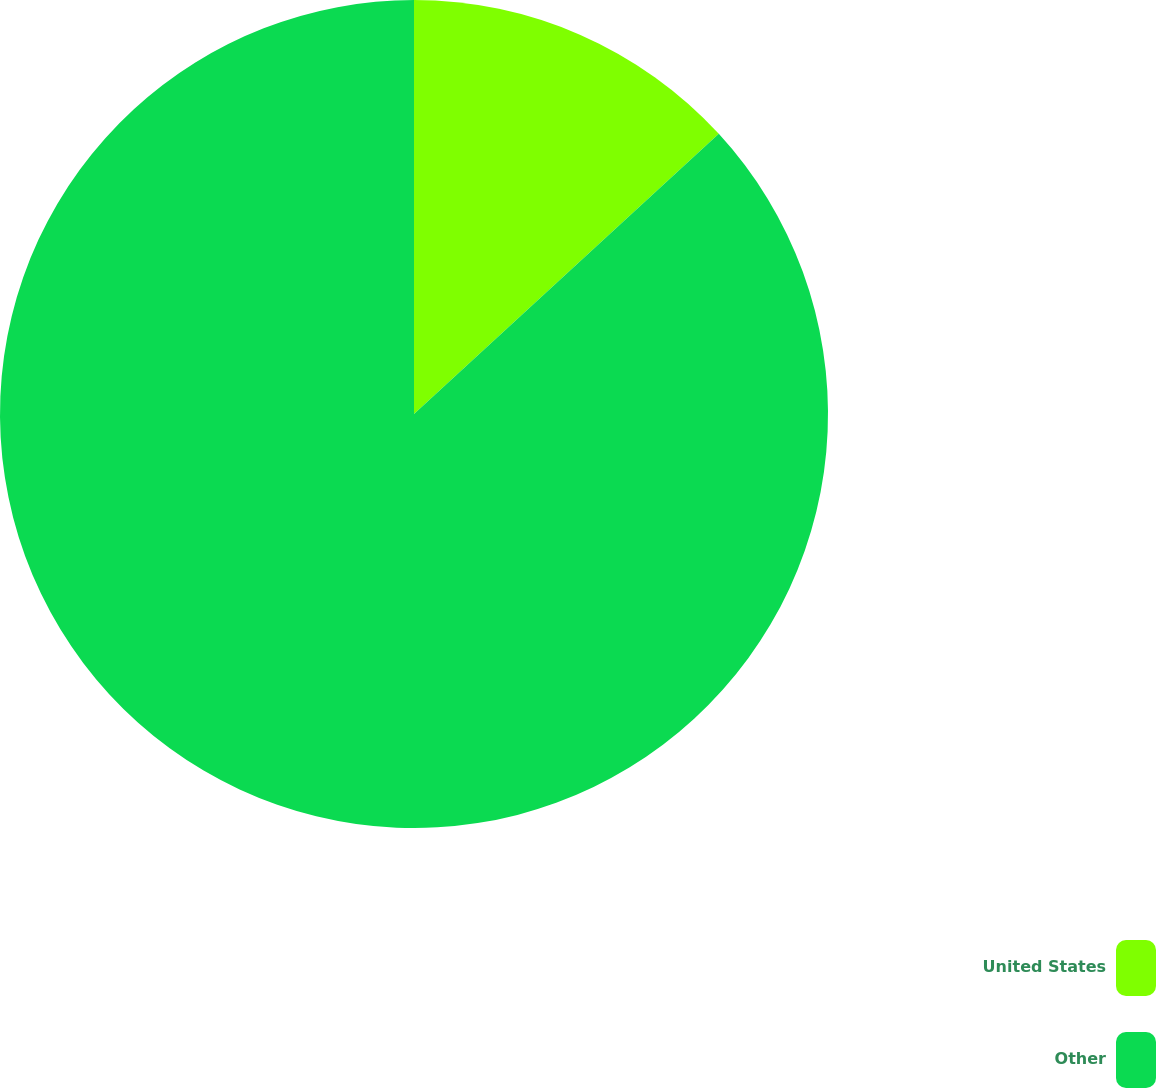Convert chart to OTSL. <chart><loc_0><loc_0><loc_500><loc_500><pie_chart><fcel>United States<fcel>Other<nl><fcel>13.17%<fcel>86.83%<nl></chart> 